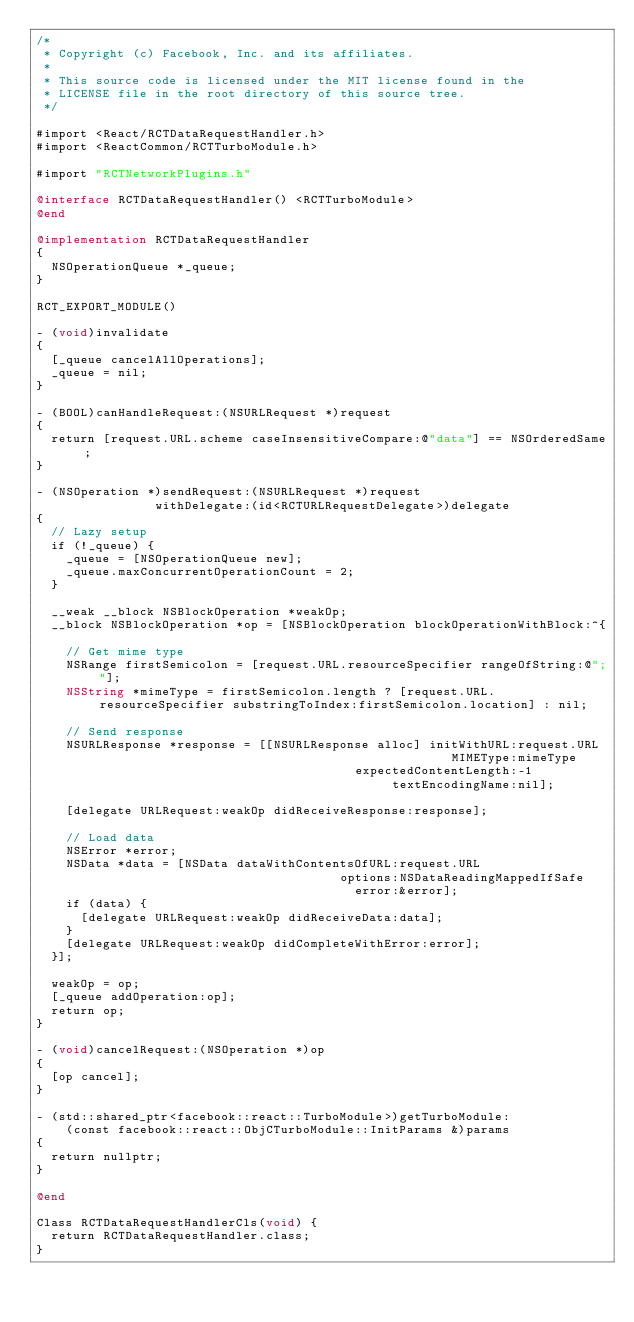Convert code to text. <code><loc_0><loc_0><loc_500><loc_500><_ObjectiveC_>/*
 * Copyright (c) Facebook, Inc. and its affiliates.
 *
 * This source code is licensed under the MIT license found in the
 * LICENSE file in the root directory of this source tree.
 */

#import <React/RCTDataRequestHandler.h>
#import <ReactCommon/RCTTurboModule.h>

#import "RCTNetworkPlugins.h"

@interface RCTDataRequestHandler() <RCTTurboModule>
@end

@implementation RCTDataRequestHandler
{
  NSOperationQueue *_queue;
}

RCT_EXPORT_MODULE()

- (void)invalidate
{
  [_queue cancelAllOperations];
  _queue = nil;
}

- (BOOL)canHandleRequest:(NSURLRequest *)request
{
  return [request.URL.scheme caseInsensitiveCompare:@"data"] == NSOrderedSame;
}

- (NSOperation *)sendRequest:(NSURLRequest *)request
                withDelegate:(id<RCTURLRequestDelegate>)delegate
{
  // Lazy setup
  if (!_queue) {
    _queue = [NSOperationQueue new];
    _queue.maxConcurrentOperationCount = 2;
  }

  __weak __block NSBlockOperation *weakOp;
  __block NSBlockOperation *op = [NSBlockOperation blockOperationWithBlock:^{

    // Get mime type
    NSRange firstSemicolon = [request.URL.resourceSpecifier rangeOfString:@";"];
    NSString *mimeType = firstSemicolon.length ? [request.URL.resourceSpecifier substringToIndex:firstSemicolon.location] : nil;

    // Send response
    NSURLResponse *response = [[NSURLResponse alloc] initWithURL:request.URL
                                                        MIMEType:mimeType
                                           expectedContentLength:-1
                                                textEncodingName:nil];

    [delegate URLRequest:weakOp didReceiveResponse:response];

    // Load data
    NSError *error;
    NSData *data = [NSData dataWithContentsOfURL:request.URL
                                         options:NSDataReadingMappedIfSafe
                                           error:&error];
    if (data) {
      [delegate URLRequest:weakOp didReceiveData:data];
    }
    [delegate URLRequest:weakOp didCompleteWithError:error];
  }];

  weakOp = op;
  [_queue addOperation:op];
  return op;
}

- (void)cancelRequest:(NSOperation *)op
{
  [op cancel];
}

- (std::shared_ptr<facebook::react::TurboModule>)getTurboModule:
    (const facebook::react::ObjCTurboModule::InitParams &)params
{
  return nullptr;
}

@end

Class RCTDataRequestHandlerCls(void) {
  return RCTDataRequestHandler.class;
}
</code> 